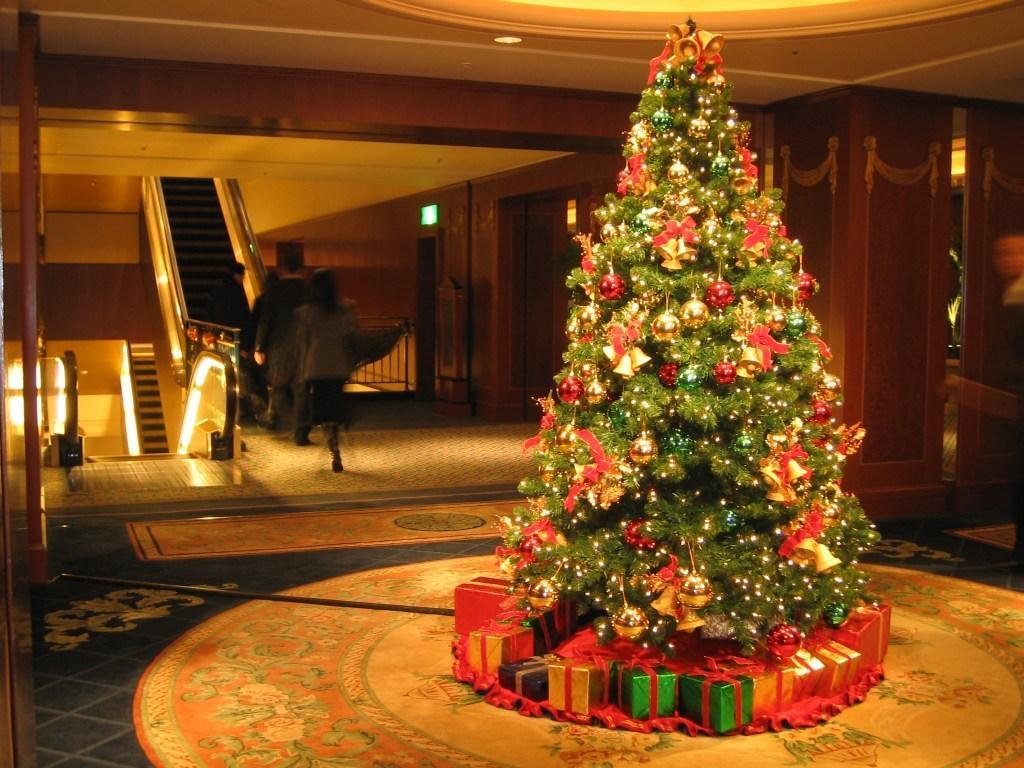Describe this image in one or two sentences. In this picture we can see a tree with some decorative items and under the tree there are some gift boxes. Behind the tree there are some people walking and in front of the people there is an escalator. On the right side of the people there is a wall with a signboard and at the top there is a ceiling light. 